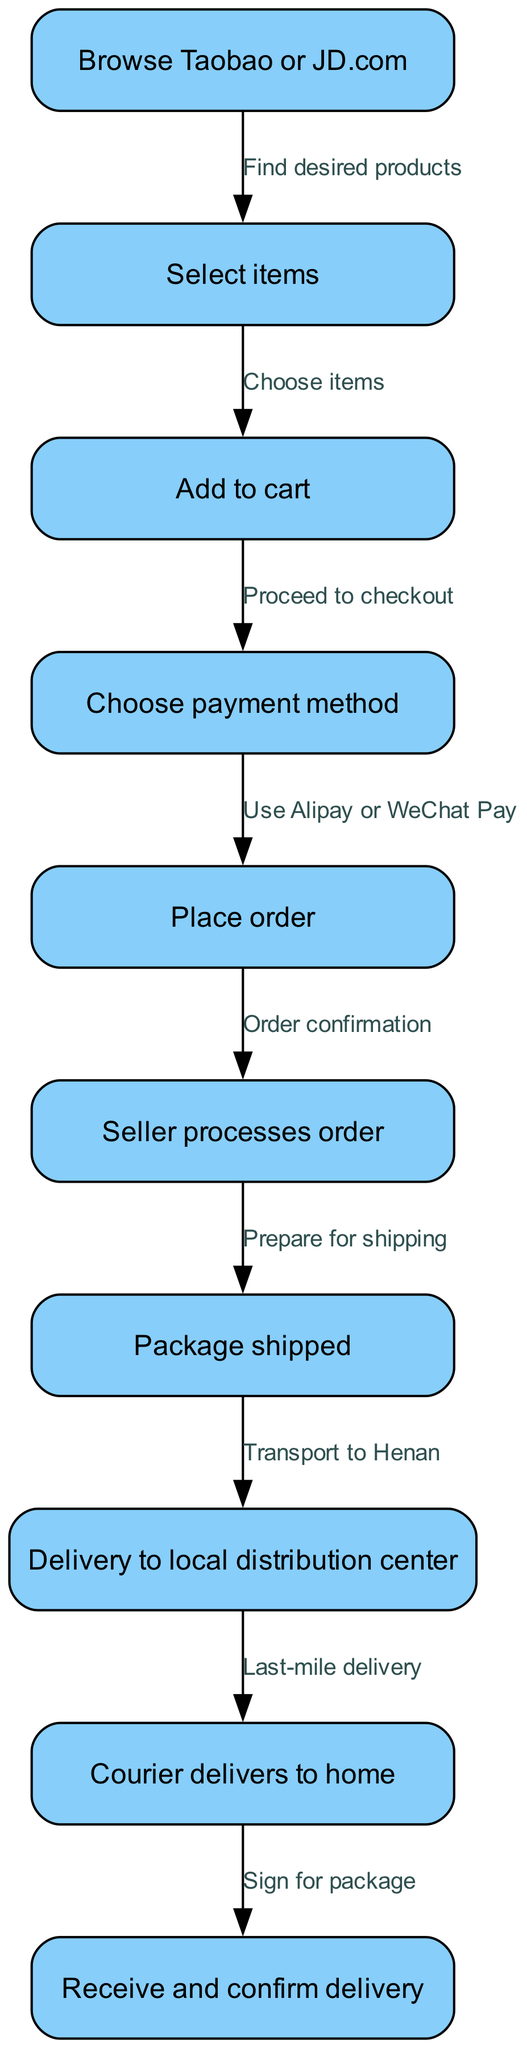What is the first step in the online shopping process? The first step, as indicated in the diagram, is "Browse Taobao or JD.com." This is the entry point into the process where users look for products.
Answer: Browse Taobao or JD.com How many nodes are there in the diagram? The diagram contains a total of 10 nodes, each representing a different step in the online shopping and delivery process. The nodes are listed individually in the diagram.
Answer: 10 What payment methods can be chosen before placing an order? The diagram specifies that users can use "Alipay or WeChat Pay" as payment methods before they confirm their order. This step follows the selection of items and addition to the cart.
Answer: Alipay or WeChat Pay Which step follows the "Seller processes order"? After the seller processes the order, the next step is "Package shipped," indicating that the seller has completed the necessary actions to prepare the product for delivery.
Answer: Package shipped What is the last step in the delivery process? The final step in the delivery process is "Receive and confirm delivery," which represents the completion of the transaction where the customer acknowledges receipt of their order.
Answer: Receive and confirm delivery What is the relationship between "Add to cart" and "Choose payment method"? The relationship is that after "Add to cart," the process flows directly to "Choose payment method." This indicates that users must select a payment method after they have added items they want to purchase.
Answer: Proceed to checkout What does "Courier delivers to home" represent in this process? This step signifies the "Last-mile delivery," which is the final delivery leg from a local distribution center to the customer's home, marking an important point in the delivery process.
Answer: Last-mile delivery How does the package get to the local distribution center? The diagram shows that the package gets to the local distribution center through the step "Transport to Henan," indicating that the package is transported from the seller to the designated local center.
Answer: Transport to Henan 